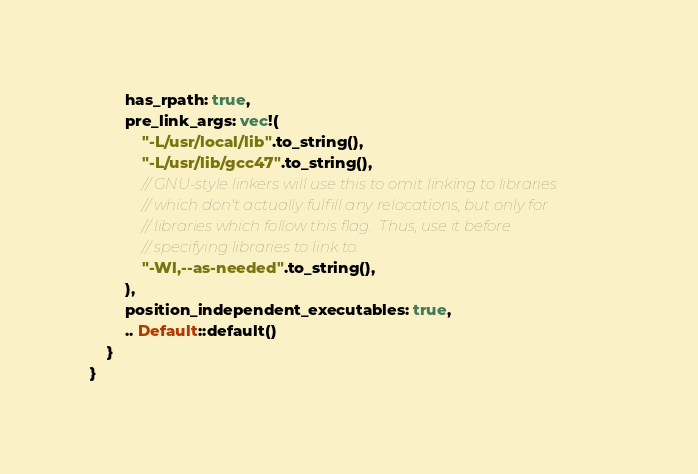Convert code to text. <code><loc_0><loc_0><loc_500><loc_500><_Rust_>        has_rpath: true,
        pre_link_args: vec!(
            "-L/usr/local/lib".to_string(),
            "-L/usr/lib/gcc47".to_string(),
            // GNU-style linkers will use this to omit linking to libraries
            // which don't actually fulfill any relocations, but only for
            // libraries which follow this flag.  Thus, use it before
            // specifying libraries to link to.
            "-Wl,--as-needed".to_string(),
        ),
        position_independent_executables: true,
        .. Default::default()
    }
}

</code> 